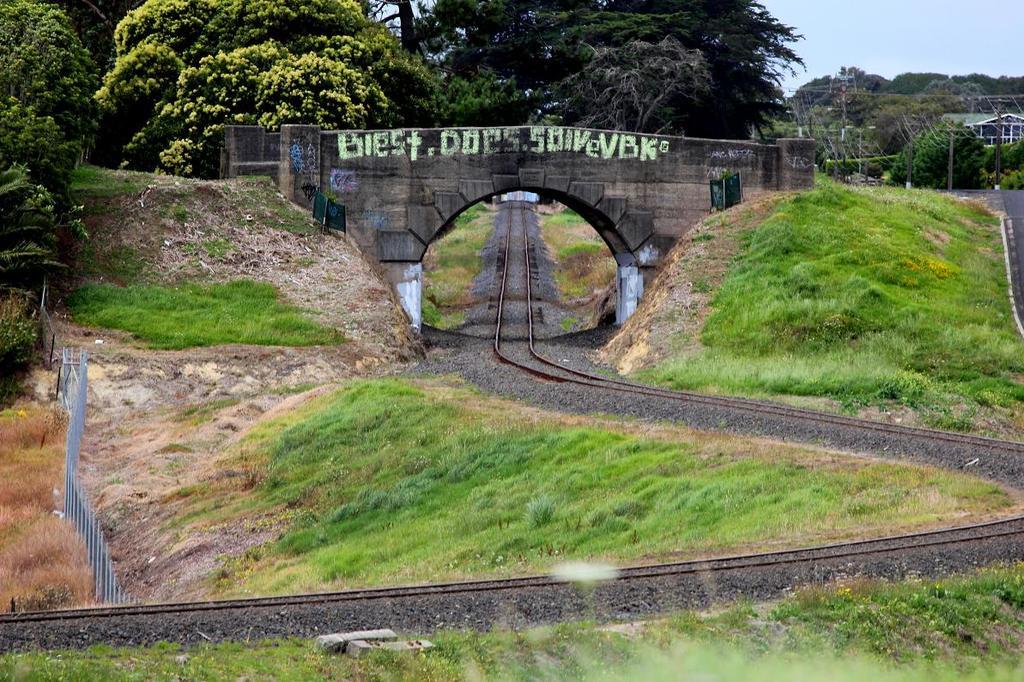What does the green graffiti over the tunnel say?
Your response must be concise. Biest does soivevbk. 